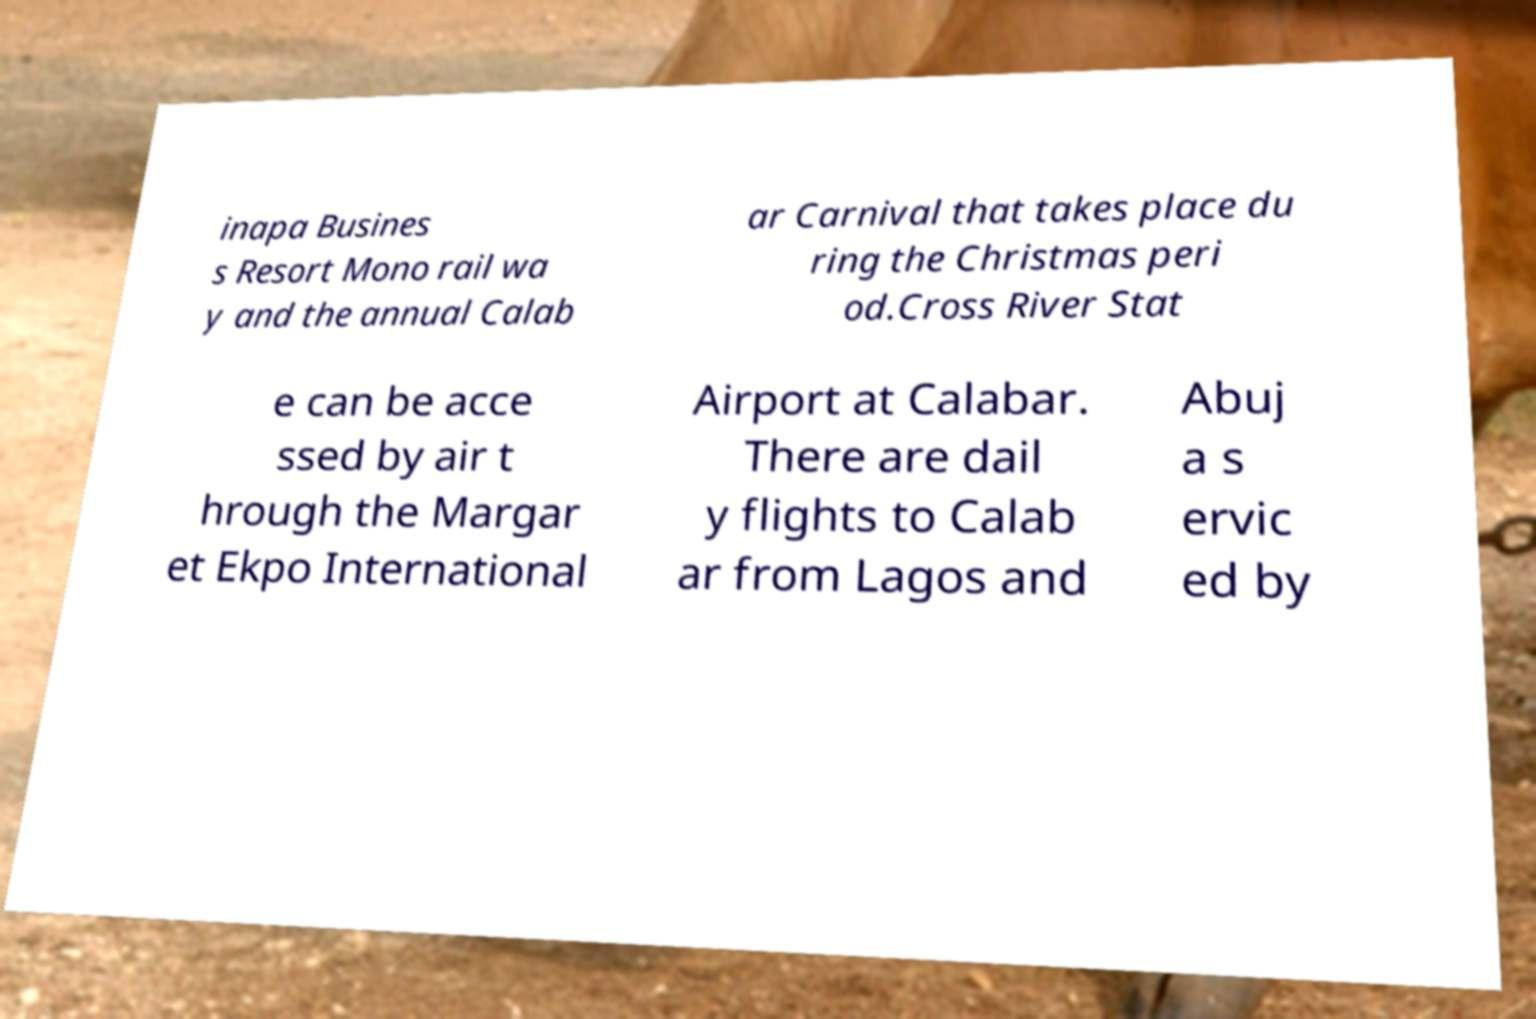Please identify and transcribe the text found in this image. inapa Busines s Resort Mono rail wa y and the annual Calab ar Carnival that takes place du ring the Christmas peri od.Cross River Stat e can be acce ssed by air t hrough the Margar et Ekpo International Airport at Calabar. There are dail y flights to Calab ar from Lagos and Abuj a s ervic ed by 